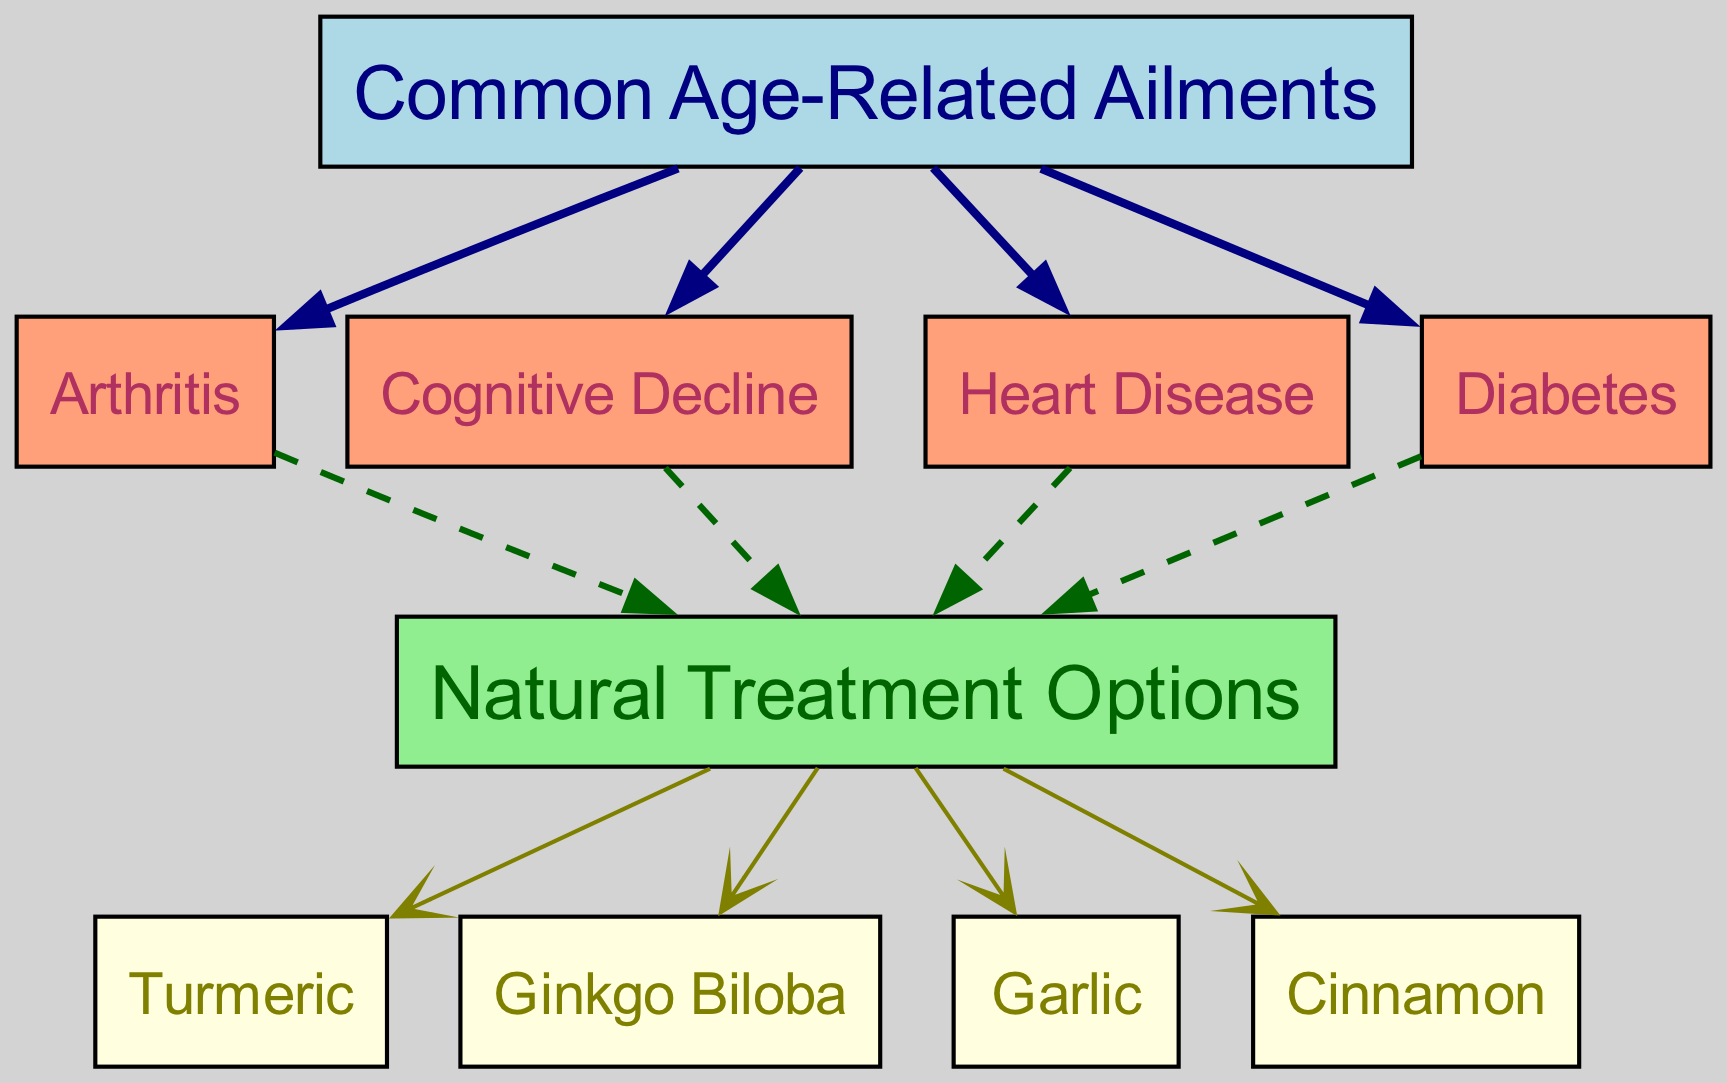What are the common age-related ailments listed in the diagram? The diagram contains the following ailments: Arthritis, Cognitive Decline, Heart Disease, and Diabetes, all of which are directly connected to the main node labeled "Common Age-Related Ailments."
Answer: Arthritis, Cognitive Decline, Heart Disease, Diabetes How many natural treatment options are mentioned in the diagram? The diagram lists four natural remedies that are linked to the "Natural Treatment Options" node: Turmeric, Ginkgo Biloba, Garlic, and Cinnamon.
Answer: 4 Which ailment is directly connected to the natural remedy 'Turmeric'? 'Turmeric' is directly connected to the node 'Natural Treatment Options' which is further connected to 'Arthritis', meaning it is one of the natural remedies for Arthritis.
Answer: Arthritis Is 'Ginkgo Biloba' used for treating Heart Disease? 'Ginkgo Biloba' is connected to the 'Natural Treatment Options' node but not specifically connected to the 'Heart Disease' node. Therefore, it is not indicated as a treatment for Heart Disease in this diagram.
Answer: No What is the relationship between Cognitive Decline and Natural Treatment Options? Cognitive Decline is connected to the 'Natural Treatment Options', indicating that there are natural remedies linked to addressing Cognitive Decline, although the exact remedies are listed separately.
Answer: Connected Which ailment has the most direct paths to natural remedies? All age-related ailments (Arthritis, Cognitive Decline, Heart Disease, Diabetes) have direct paths leading to the node 'Natural Treatment Options', so they all share an equal number of paths—each has one direct connection.
Answer: Equal paths What color is used for the 'Natural Treatment Options' node? In the diagram, the 'Natural Treatment Options' node is filled with light green color, distinguishing it from the other colored nodes representing ailments.
Answer: Light green How many edges connect from age-related ailments to specific ailments? There are four edges connecting the 'Common Age-Related Ailments' node to each of the four individual ailments, indicating a direct relationship of all listed ailments to the main category.
Answer: 4 